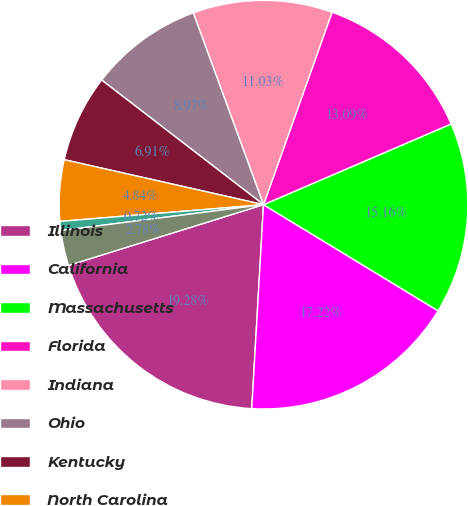Convert chart. <chart><loc_0><loc_0><loc_500><loc_500><pie_chart><fcel>Illinois<fcel>California<fcel>Massachusetts<fcel>Florida<fcel>Indiana<fcel>Ohio<fcel>Kentucky<fcel>North Carolina<fcel>Texas<fcel>Pennsylvania<nl><fcel>19.28%<fcel>17.22%<fcel>15.16%<fcel>13.09%<fcel>11.03%<fcel>8.97%<fcel>6.91%<fcel>4.84%<fcel>0.72%<fcel>2.78%<nl></chart> 